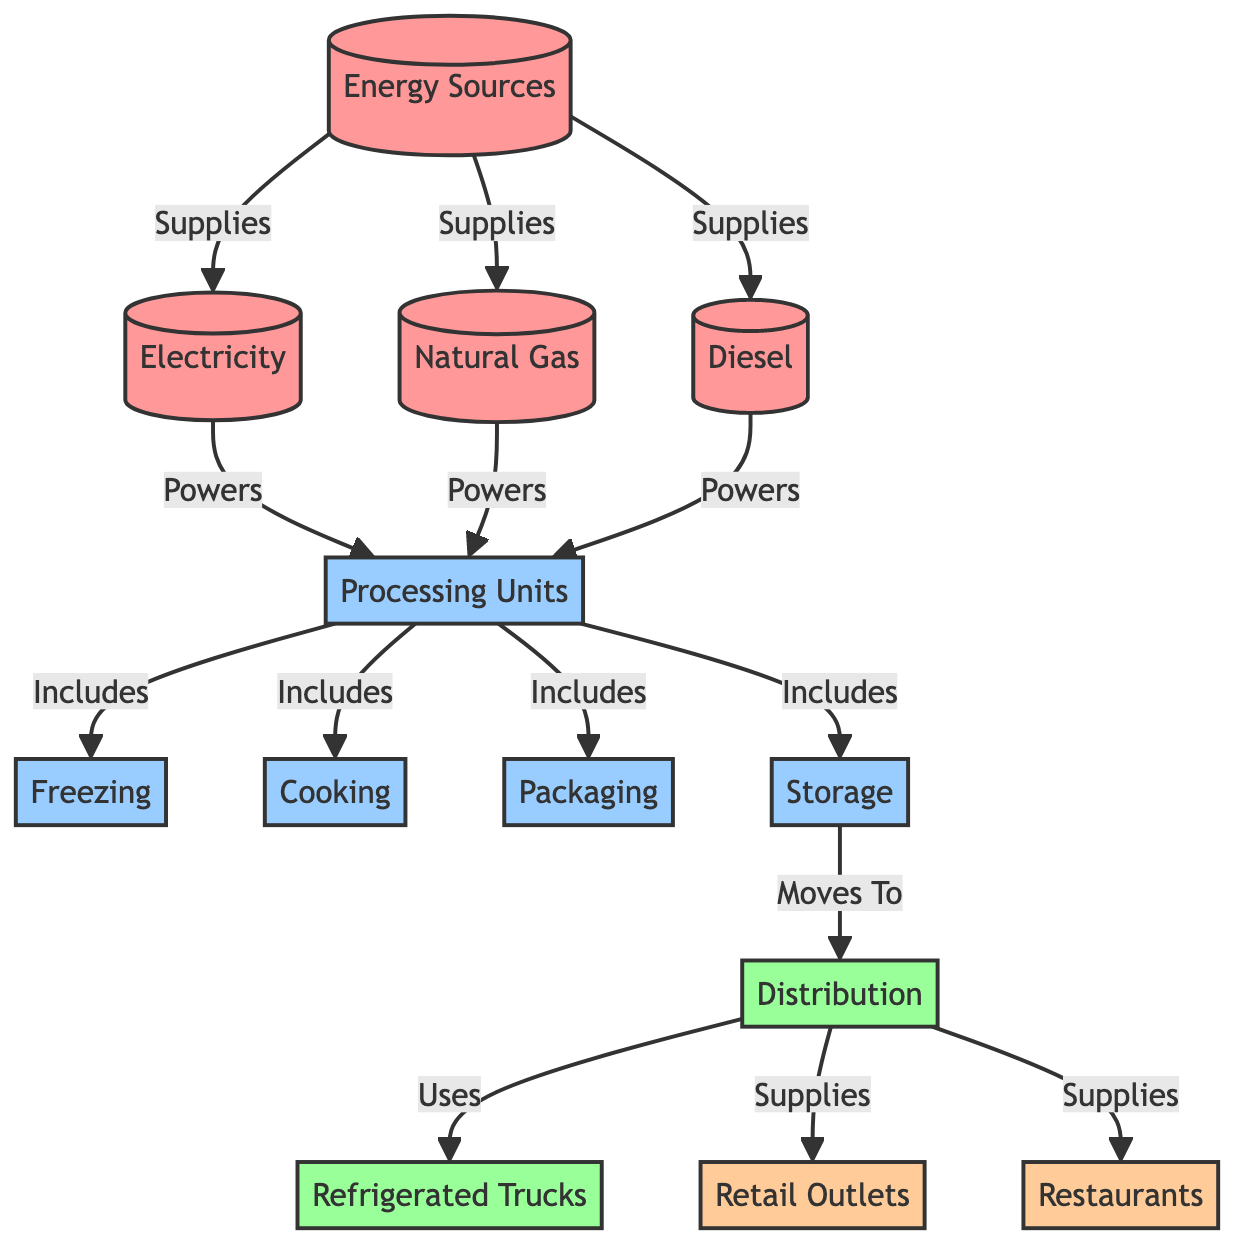What's the total number of energy sources in the diagram? The diagram lists three distinct energy sources: Electricity, Natural Gas, and Diesel. By counting these nodes, we find there are a total of three energy sources.
Answer: 3 Which processing unit is responsible for packaging? The node labeled "Packaging" specifically identifies it as one of the processing units. Therefore, it is directly responsible for the packaging stage in the food chain.
Answer: Packaging How many endpoints are there in the diagram? The endpoints listed in the diagram are Retail Outlets and Restaurants. By counting these nodes, we find there are two endpoints in total.
Answer: 2 What powers the processing units? The processing units are powered by the three energy sources: Electricity, Natural Gas, and Diesel. They are identified as supplying power to the processing units collectively.
Answer: Electricity, Natural Gas, Diesel Which processing unit comes after storage in the flow? Following "Storage", the flow moves to "Distribution," which indicates that the storage phase is directly followed by the distribution phase in the chain.
Answer: Distribution How many processing units are included in the diagram? The diagram lists four processing units: Freezing, Cooking, Packaging, and Storage. By counting these nodes, we determine that there are a total of four processing units included.
Answer: 4 What moves to the distribution phase? The "Storage" processing unit is the one that moves to the "Distribution" phase in the diagram. It indicates the flow from storage directly into distribution.
Answer: Storage What is the function of refrigerated trucks in the flow? Refrigerated Trucks are used in the distribution phase, specifically noted as the mode that utilizes the distribution flow for delivering seafood products.
Answer: Uses Which energy source is not listed in the processing units? All processing units are powered by Electricity, Natural Gas, and Diesel, yet none of the processing stages specifically involves energy production or consumption as a direct component, indicating that processing units do not explicitly list energy sources. The energy source itself is not counted among processing units.
Answer: Energy sources 